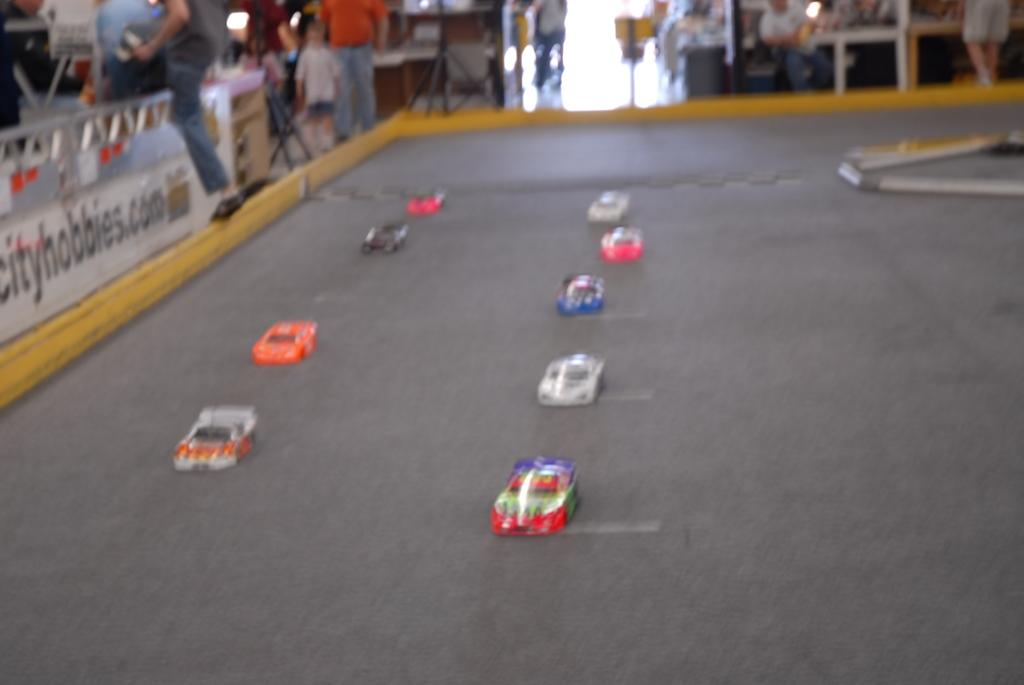Who or what can be seen in the image? There are people in the image. What else is present in the image besides people? There are toys, a board with text on the left side, stands, and white-colored poles in the image. What type of sock is hanging from the cloud in the image? There is no cloud or sock present in the image. How does the cloud affect the people and toys in the image? There is no cloud in the image, so it cannot affect the people or toys. 